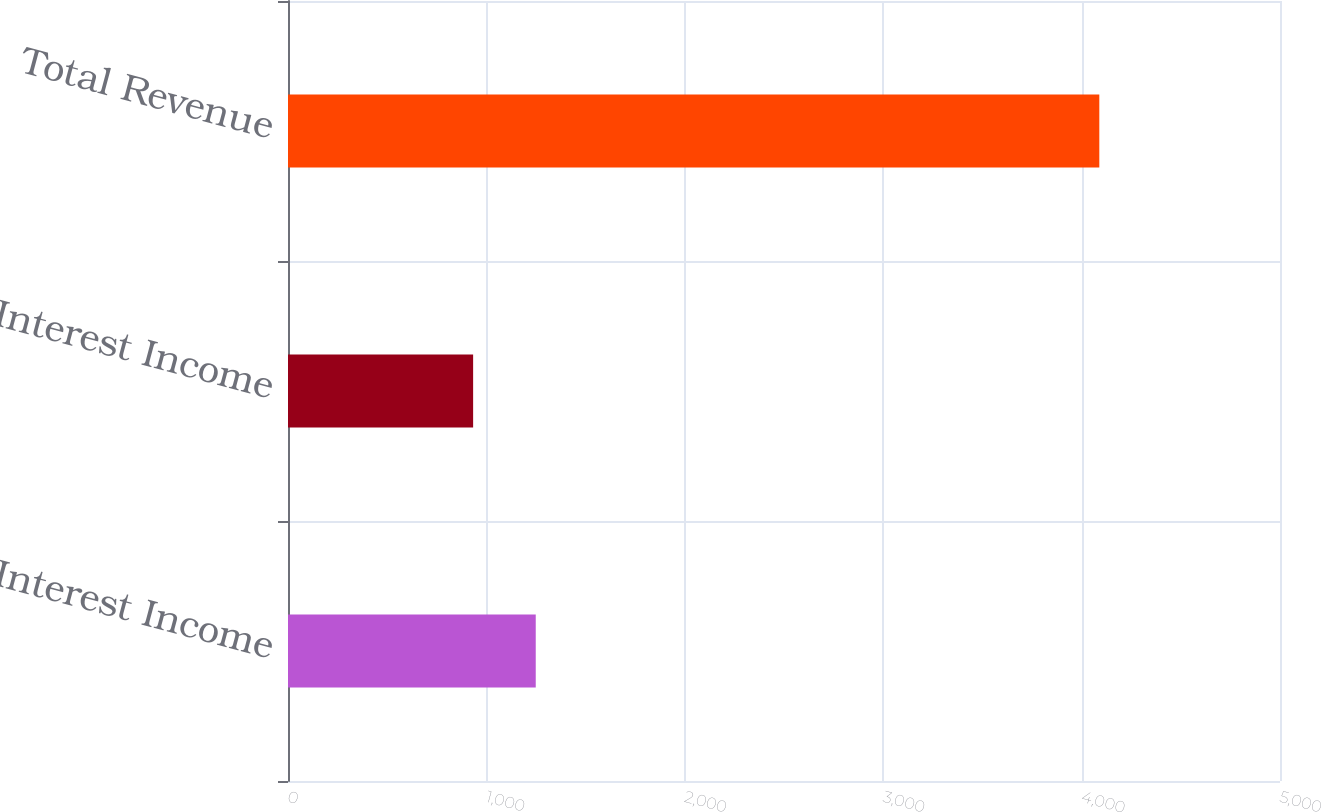Convert chart to OTSL. <chart><loc_0><loc_0><loc_500><loc_500><bar_chart><fcel>Interest Income<fcel>Net Interest Income<fcel>Total Revenue<nl><fcel>1248.72<fcel>933.1<fcel>4089.3<nl></chart> 